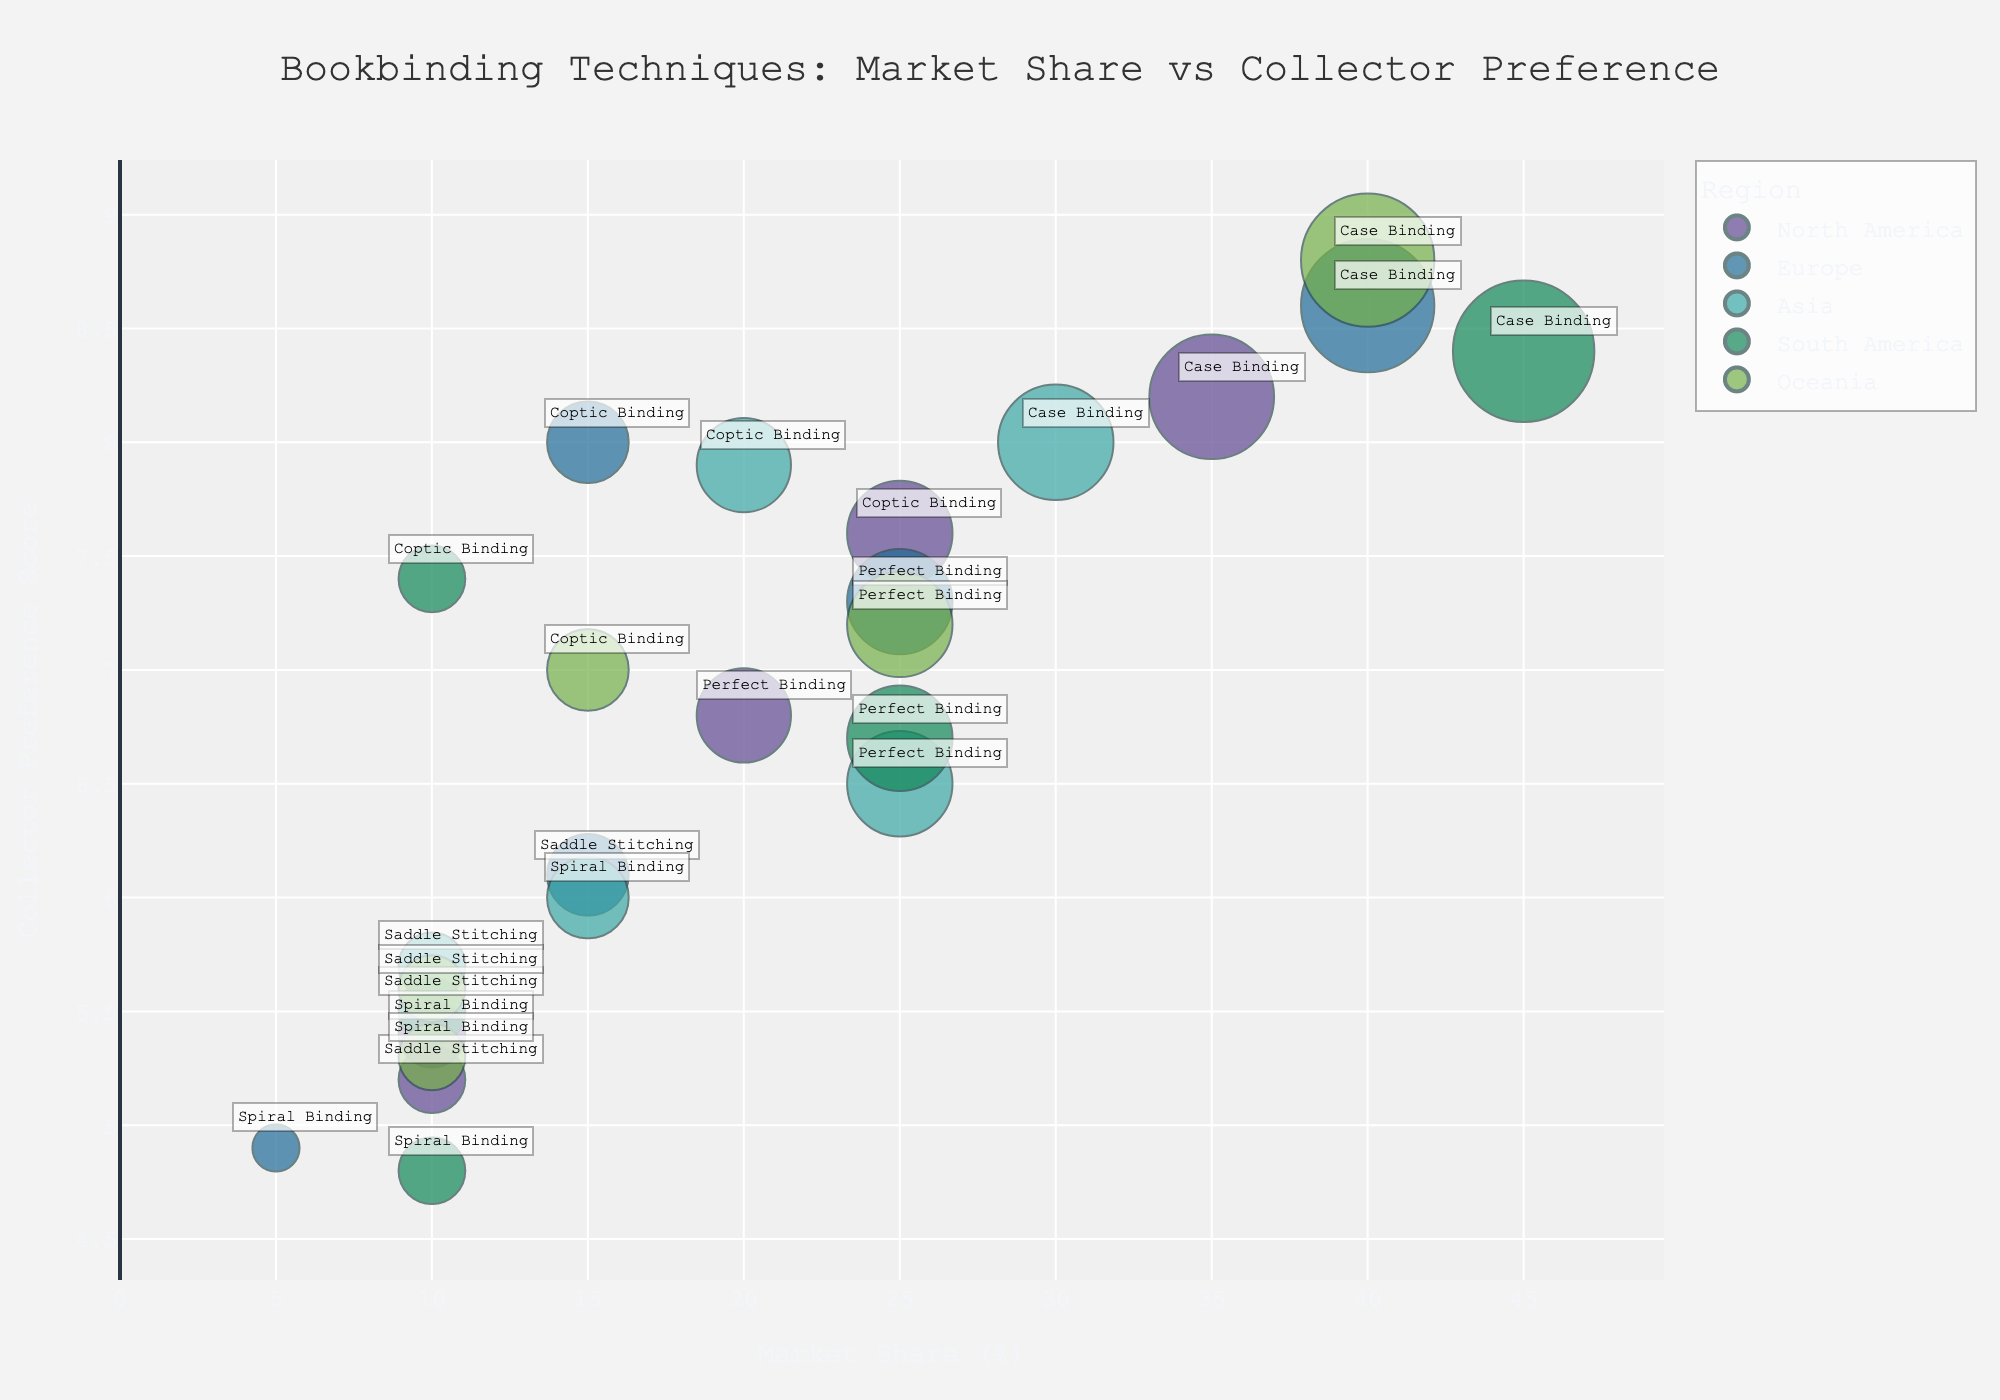What is the title of the chart? The title of the chart is displayed prominently at the top center of the figure. Read the text directly to find the title.
Answer: Bookbinding Techniques: Market Share vs Collector Preference How many different regions are represented in the chart? Each color in the bubble chart represents a different region. By counting the number of unique colors in the legend or directly from the bubbles, you can find the number of regions.
Answer: 5 Which bookbinding technique has the highest market share in North America, and what is its market share percentage? Look for the bubbles colored for North America (check the legend for the specific color) and compare their sizes. The largest bubble indicates the highest market share. Hovering over the bubble gives the market share percentage.
Answer: Case Binding, 35% Which region has the highest collector preference score for Case Binding? Identify all Case Binding bubbles and compare their heights along the y-axis. The highest bubble corresponds to the highest preference score.
Answer: Oceania In Europe, what is the sum of the market share percentages for Case Binding and Perfect Binding? Find the bubbles for Europe and identify those labeled "Case Binding" and "Perfect Binding." Add their market share percentages together.
Answer: 40% + 25% = 65% Compare the collector preference scores for Coptic Binding in Asia and South America. Which region shows a higher preference? Identify the Coptic Binding bubbles for Asia and South America and compare their positions on the y-axis. The higher y-position indicates a higher preference score.
Answer: Asia Which bookbinding technique has the lowest collector preference score across all regions? Look for the bubble with the lowest position on the y-axis across all regions. Hover over to see the technique name.
Answer: Spiral Binding How does the market share for Perfect Binding in Asia compare to that in Europe? Locate the Perfect Binding bubbles in Asia and Europe and compare their sizes along the x-axis. Describe the relative sizes.
Answer: Asia has a smaller market share for Perfect Binding (25%) compared to Europe (25%) Which region has the most varied collector preference scores? Examine the spread of bubbles along the y-axis for each region. The region with the widest range of heights has the most varied scores.
Answer: North America What is the average collector preference score for Case Binding across all regions? Identify all Case Binding bubbles and sum their collector preference scores. Divide the total by the number of regions to find the average.
Answer: (8.2 + 8.6 + 8.0 + 8.4 + 8.8) / 5 = 8.4 